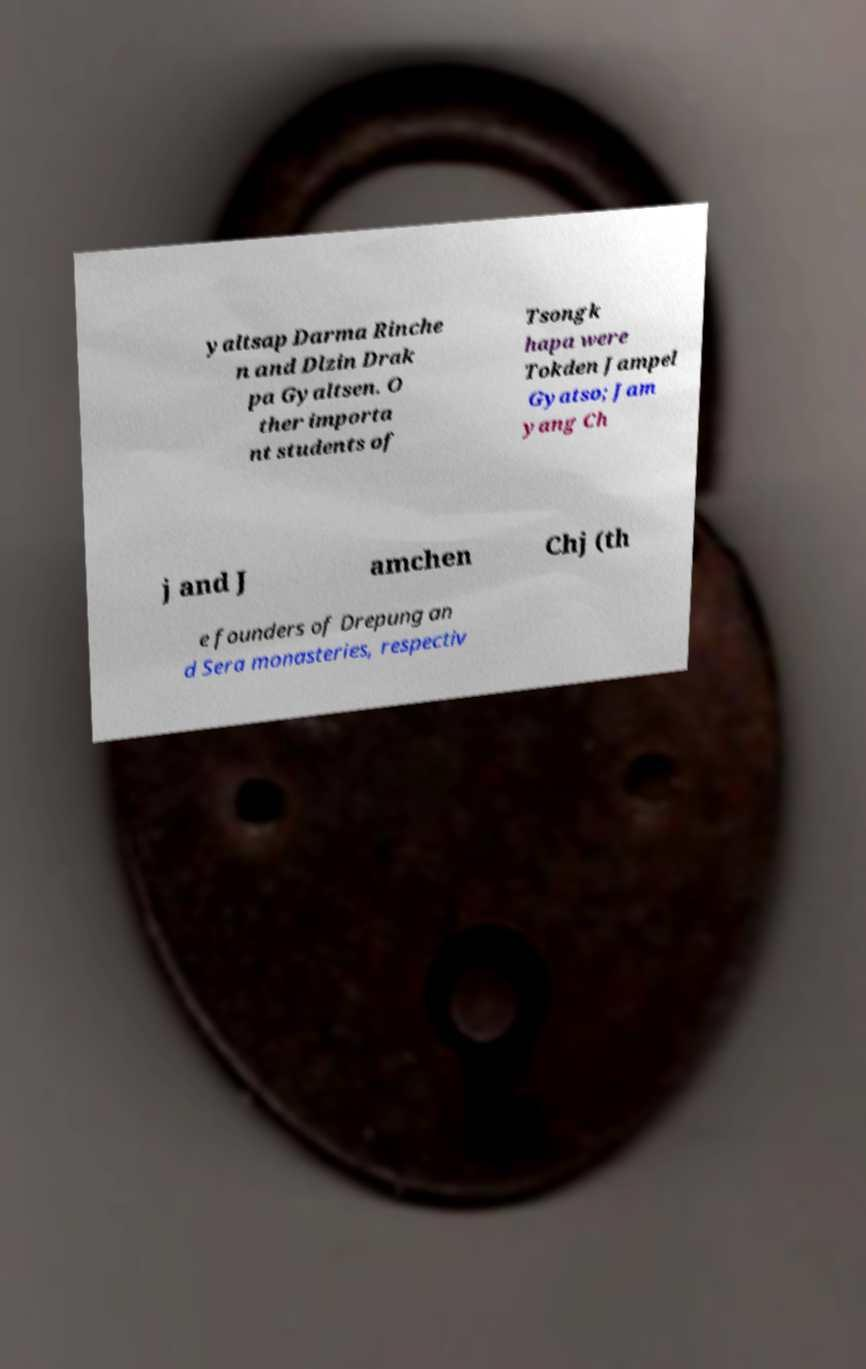What messages or text are displayed in this image? I need them in a readable, typed format. yaltsap Darma Rinche n and Dlzin Drak pa Gyaltsen. O ther importa nt students of Tsongk hapa were Tokden Jampel Gyatso; Jam yang Ch j and J amchen Chj (th e founders of Drepung an d Sera monasteries, respectiv 